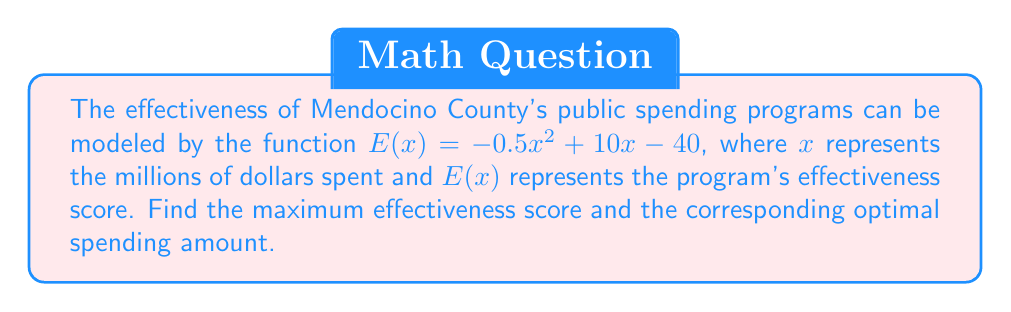Solve this math problem. To find the maximum point of this quadratic function, we need to follow these steps:

1) The function $E(x) = -0.5x^2 + 10x - 40$ is a quadratic function in the form $f(x) = ax^2 + bx + c$, where $a = -0.5$, $b = 10$, and $c = -40$.

2) For a quadratic function, the x-coordinate of the vertex (which gives the maximum point for a downward-facing parabola) is given by the formula:

   $$x = -\frac{b}{2a}$$

3) Substituting our values:

   $$x = -\frac{10}{2(-0.5)} = -\frac{10}{-1} = 10$$

4) To find the maximum effectiveness score, we need to calculate $E(10)$:

   $$E(10) = -0.5(10)^2 + 10(10) - 40$$
   $$= -0.5(100) + 100 - 40$$
   $$= -50 + 100 - 40$$
   $$= 10$$

5) Therefore, the maximum effectiveness score is 10, occurring when $x = 10$ million dollars are spent.
Answer: Maximum effectiveness score: 10; Optimal spending: $10 million 